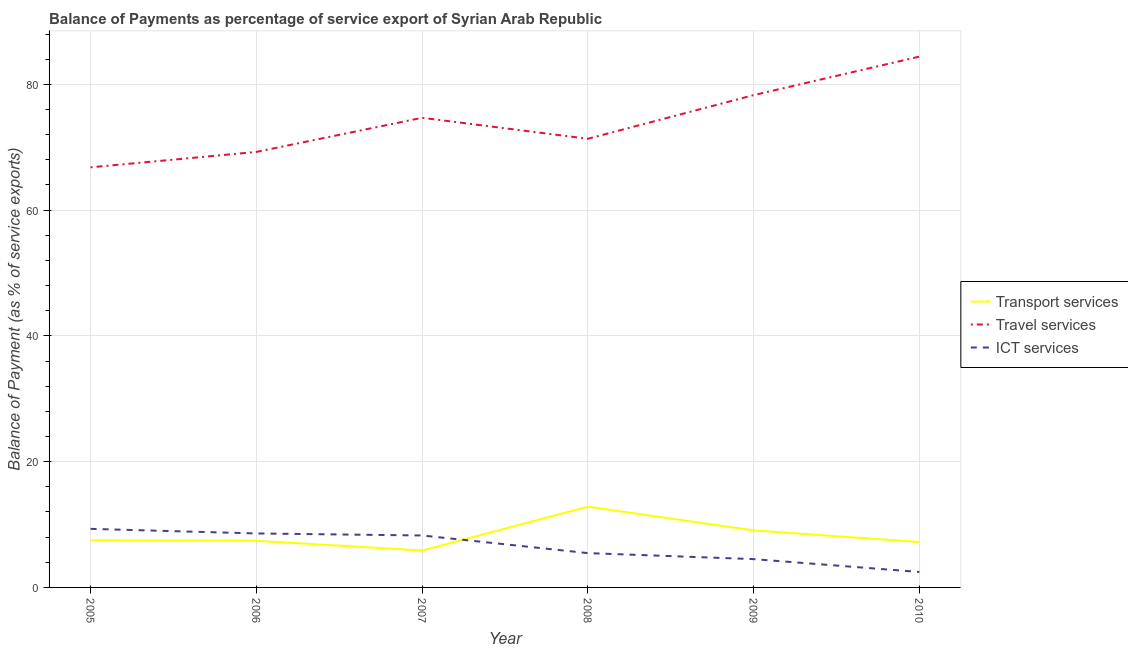Does the line corresponding to balance of payment of transport services intersect with the line corresponding to balance of payment of ict services?
Ensure brevity in your answer.  Yes. What is the balance of payment of transport services in 2006?
Your answer should be compact. 7.42. Across all years, what is the maximum balance of payment of transport services?
Make the answer very short. 12.84. Across all years, what is the minimum balance of payment of travel services?
Your answer should be very brief. 66.8. What is the total balance of payment of travel services in the graph?
Offer a very short reply. 444.79. What is the difference between the balance of payment of transport services in 2007 and that in 2009?
Keep it short and to the point. -3.2. What is the difference between the balance of payment of transport services in 2010 and the balance of payment of ict services in 2009?
Your answer should be compact. 2.72. What is the average balance of payment of transport services per year?
Your answer should be compact. 8.32. In the year 2005, what is the difference between the balance of payment of transport services and balance of payment of travel services?
Offer a terse response. -59.31. What is the ratio of the balance of payment of travel services in 2005 to that in 2006?
Your answer should be compact. 0.96. What is the difference between the highest and the second highest balance of payment of ict services?
Offer a very short reply. 0.73. What is the difference between the highest and the lowest balance of payment of travel services?
Make the answer very short. 17.61. In how many years, is the balance of payment of transport services greater than the average balance of payment of transport services taken over all years?
Your answer should be very brief. 2. Is the sum of the balance of payment of transport services in 2005 and 2006 greater than the maximum balance of payment of ict services across all years?
Provide a short and direct response. Yes. Is it the case that in every year, the sum of the balance of payment of transport services and balance of payment of travel services is greater than the balance of payment of ict services?
Make the answer very short. Yes. Does the balance of payment of ict services monotonically increase over the years?
Provide a short and direct response. No. Is the balance of payment of travel services strictly greater than the balance of payment of ict services over the years?
Make the answer very short. Yes. Is the balance of payment of travel services strictly less than the balance of payment of ict services over the years?
Offer a terse response. No. How many years are there in the graph?
Make the answer very short. 6. Does the graph contain any zero values?
Your response must be concise. No. How are the legend labels stacked?
Your answer should be compact. Vertical. What is the title of the graph?
Your response must be concise. Balance of Payments as percentage of service export of Syrian Arab Republic. What is the label or title of the X-axis?
Provide a short and direct response. Year. What is the label or title of the Y-axis?
Your response must be concise. Balance of Payment (as % of service exports). What is the Balance of Payment (as % of service exports) of Transport services in 2005?
Offer a very short reply. 7.49. What is the Balance of Payment (as % of service exports) of Travel services in 2005?
Offer a terse response. 66.8. What is the Balance of Payment (as % of service exports) in ICT services in 2005?
Give a very brief answer. 9.31. What is the Balance of Payment (as % of service exports) in Transport services in 2006?
Give a very brief answer. 7.42. What is the Balance of Payment (as % of service exports) of Travel services in 2006?
Ensure brevity in your answer.  69.25. What is the Balance of Payment (as % of service exports) in ICT services in 2006?
Your answer should be compact. 8.58. What is the Balance of Payment (as % of service exports) of Transport services in 2007?
Offer a terse response. 5.87. What is the Balance of Payment (as % of service exports) of Travel services in 2007?
Your answer should be very brief. 74.68. What is the Balance of Payment (as % of service exports) of ICT services in 2007?
Ensure brevity in your answer.  8.26. What is the Balance of Payment (as % of service exports) of Transport services in 2008?
Make the answer very short. 12.84. What is the Balance of Payment (as % of service exports) of Travel services in 2008?
Your answer should be compact. 71.35. What is the Balance of Payment (as % of service exports) of ICT services in 2008?
Offer a terse response. 5.46. What is the Balance of Payment (as % of service exports) in Transport services in 2009?
Give a very brief answer. 9.07. What is the Balance of Payment (as % of service exports) in Travel services in 2009?
Make the answer very short. 78.29. What is the Balance of Payment (as % of service exports) in ICT services in 2009?
Your answer should be compact. 4.5. What is the Balance of Payment (as % of service exports) of Transport services in 2010?
Provide a short and direct response. 7.22. What is the Balance of Payment (as % of service exports) in Travel services in 2010?
Keep it short and to the point. 84.41. What is the Balance of Payment (as % of service exports) of ICT services in 2010?
Keep it short and to the point. 2.46. Across all years, what is the maximum Balance of Payment (as % of service exports) of Transport services?
Give a very brief answer. 12.84. Across all years, what is the maximum Balance of Payment (as % of service exports) in Travel services?
Ensure brevity in your answer.  84.41. Across all years, what is the maximum Balance of Payment (as % of service exports) in ICT services?
Make the answer very short. 9.31. Across all years, what is the minimum Balance of Payment (as % of service exports) in Transport services?
Your answer should be compact. 5.87. Across all years, what is the minimum Balance of Payment (as % of service exports) of Travel services?
Keep it short and to the point. 66.8. Across all years, what is the minimum Balance of Payment (as % of service exports) in ICT services?
Your response must be concise. 2.46. What is the total Balance of Payment (as % of service exports) in Transport services in the graph?
Your answer should be compact. 49.91. What is the total Balance of Payment (as % of service exports) in Travel services in the graph?
Provide a short and direct response. 444.79. What is the total Balance of Payment (as % of service exports) of ICT services in the graph?
Ensure brevity in your answer.  38.57. What is the difference between the Balance of Payment (as % of service exports) in Transport services in 2005 and that in 2006?
Give a very brief answer. 0.07. What is the difference between the Balance of Payment (as % of service exports) of Travel services in 2005 and that in 2006?
Provide a succinct answer. -2.45. What is the difference between the Balance of Payment (as % of service exports) of ICT services in 2005 and that in 2006?
Give a very brief answer. 0.73. What is the difference between the Balance of Payment (as % of service exports) in Transport services in 2005 and that in 2007?
Provide a succinct answer. 1.62. What is the difference between the Balance of Payment (as % of service exports) in Travel services in 2005 and that in 2007?
Your answer should be compact. -7.88. What is the difference between the Balance of Payment (as % of service exports) of ICT services in 2005 and that in 2007?
Provide a short and direct response. 1.05. What is the difference between the Balance of Payment (as % of service exports) in Transport services in 2005 and that in 2008?
Your answer should be very brief. -5.35. What is the difference between the Balance of Payment (as % of service exports) of Travel services in 2005 and that in 2008?
Ensure brevity in your answer.  -4.54. What is the difference between the Balance of Payment (as % of service exports) of ICT services in 2005 and that in 2008?
Offer a very short reply. 3.85. What is the difference between the Balance of Payment (as % of service exports) of Transport services in 2005 and that in 2009?
Give a very brief answer. -1.57. What is the difference between the Balance of Payment (as % of service exports) of Travel services in 2005 and that in 2009?
Give a very brief answer. -11.48. What is the difference between the Balance of Payment (as % of service exports) of ICT services in 2005 and that in 2009?
Offer a terse response. 4.81. What is the difference between the Balance of Payment (as % of service exports) in Transport services in 2005 and that in 2010?
Provide a short and direct response. 0.28. What is the difference between the Balance of Payment (as % of service exports) in Travel services in 2005 and that in 2010?
Your response must be concise. -17.61. What is the difference between the Balance of Payment (as % of service exports) in ICT services in 2005 and that in 2010?
Your answer should be very brief. 6.86. What is the difference between the Balance of Payment (as % of service exports) in Transport services in 2006 and that in 2007?
Your answer should be compact. 1.55. What is the difference between the Balance of Payment (as % of service exports) in Travel services in 2006 and that in 2007?
Provide a succinct answer. -5.43. What is the difference between the Balance of Payment (as % of service exports) of ICT services in 2006 and that in 2007?
Your response must be concise. 0.32. What is the difference between the Balance of Payment (as % of service exports) of Transport services in 2006 and that in 2008?
Provide a short and direct response. -5.42. What is the difference between the Balance of Payment (as % of service exports) in Travel services in 2006 and that in 2008?
Offer a terse response. -2.09. What is the difference between the Balance of Payment (as % of service exports) of ICT services in 2006 and that in 2008?
Offer a very short reply. 3.13. What is the difference between the Balance of Payment (as % of service exports) in Transport services in 2006 and that in 2009?
Your answer should be very brief. -1.65. What is the difference between the Balance of Payment (as % of service exports) in Travel services in 2006 and that in 2009?
Ensure brevity in your answer.  -9.03. What is the difference between the Balance of Payment (as % of service exports) of ICT services in 2006 and that in 2009?
Your response must be concise. 4.08. What is the difference between the Balance of Payment (as % of service exports) in Transport services in 2006 and that in 2010?
Your answer should be very brief. 0.2. What is the difference between the Balance of Payment (as % of service exports) in Travel services in 2006 and that in 2010?
Provide a succinct answer. -15.16. What is the difference between the Balance of Payment (as % of service exports) in ICT services in 2006 and that in 2010?
Your answer should be very brief. 6.13. What is the difference between the Balance of Payment (as % of service exports) in Transport services in 2007 and that in 2008?
Your response must be concise. -6.97. What is the difference between the Balance of Payment (as % of service exports) in Travel services in 2007 and that in 2008?
Keep it short and to the point. 3.33. What is the difference between the Balance of Payment (as % of service exports) of ICT services in 2007 and that in 2008?
Offer a very short reply. 2.8. What is the difference between the Balance of Payment (as % of service exports) of Transport services in 2007 and that in 2009?
Give a very brief answer. -3.2. What is the difference between the Balance of Payment (as % of service exports) of Travel services in 2007 and that in 2009?
Provide a succinct answer. -3.6. What is the difference between the Balance of Payment (as % of service exports) in ICT services in 2007 and that in 2009?
Your response must be concise. 3.76. What is the difference between the Balance of Payment (as % of service exports) in Transport services in 2007 and that in 2010?
Keep it short and to the point. -1.35. What is the difference between the Balance of Payment (as % of service exports) in Travel services in 2007 and that in 2010?
Give a very brief answer. -9.73. What is the difference between the Balance of Payment (as % of service exports) in ICT services in 2007 and that in 2010?
Your answer should be very brief. 5.81. What is the difference between the Balance of Payment (as % of service exports) of Transport services in 2008 and that in 2009?
Provide a succinct answer. 3.78. What is the difference between the Balance of Payment (as % of service exports) of Travel services in 2008 and that in 2009?
Offer a very short reply. -6.94. What is the difference between the Balance of Payment (as % of service exports) in ICT services in 2008 and that in 2009?
Your response must be concise. 0.96. What is the difference between the Balance of Payment (as % of service exports) in Transport services in 2008 and that in 2010?
Offer a terse response. 5.63. What is the difference between the Balance of Payment (as % of service exports) of Travel services in 2008 and that in 2010?
Offer a terse response. -13.07. What is the difference between the Balance of Payment (as % of service exports) in ICT services in 2008 and that in 2010?
Your response must be concise. 3. What is the difference between the Balance of Payment (as % of service exports) in Transport services in 2009 and that in 2010?
Offer a very short reply. 1.85. What is the difference between the Balance of Payment (as % of service exports) of Travel services in 2009 and that in 2010?
Provide a short and direct response. -6.13. What is the difference between the Balance of Payment (as % of service exports) in ICT services in 2009 and that in 2010?
Make the answer very short. 2.05. What is the difference between the Balance of Payment (as % of service exports) of Transport services in 2005 and the Balance of Payment (as % of service exports) of Travel services in 2006?
Offer a terse response. -61.76. What is the difference between the Balance of Payment (as % of service exports) in Transport services in 2005 and the Balance of Payment (as % of service exports) in ICT services in 2006?
Your answer should be very brief. -1.09. What is the difference between the Balance of Payment (as % of service exports) in Travel services in 2005 and the Balance of Payment (as % of service exports) in ICT services in 2006?
Ensure brevity in your answer.  58.22. What is the difference between the Balance of Payment (as % of service exports) of Transport services in 2005 and the Balance of Payment (as % of service exports) of Travel services in 2007?
Give a very brief answer. -67.19. What is the difference between the Balance of Payment (as % of service exports) in Transport services in 2005 and the Balance of Payment (as % of service exports) in ICT services in 2007?
Your answer should be very brief. -0.77. What is the difference between the Balance of Payment (as % of service exports) of Travel services in 2005 and the Balance of Payment (as % of service exports) of ICT services in 2007?
Your response must be concise. 58.54. What is the difference between the Balance of Payment (as % of service exports) in Transport services in 2005 and the Balance of Payment (as % of service exports) in Travel services in 2008?
Your answer should be compact. -63.86. What is the difference between the Balance of Payment (as % of service exports) of Transport services in 2005 and the Balance of Payment (as % of service exports) of ICT services in 2008?
Your response must be concise. 2.03. What is the difference between the Balance of Payment (as % of service exports) of Travel services in 2005 and the Balance of Payment (as % of service exports) of ICT services in 2008?
Give a very brief answer. 61.35. What is the difference between the Balance of Payment (as % of service exports) of Transport services in 2005 and the Balance of Payment (as % of service exports) of Travel services in 2009?
Provide a short and direct response. -70.8. What is the difference between the Balance of Payment (as % of service exports) of Transport services in 2005 and the Balance of Payment (as % of service exports) of ICT services in 2009?
Keep it short and to the point. 2.99. What is the difference between the Balance of Payment (as % of service exports) in Travel services in 2005 and the Balance of Payment (as % of service exports) in ICT services in 2009?
Make the answer very short. 62.3. What is the difference between the Balance of Payment (as % of service exports) of Transport services in 2005 and the Balance of Payment (as % of service exports) of Travel services in 2010?
Ensure brevity in your answer.  -76.92. What is the difference between the Balance of Payment (as % of service exports) of Transport services in 2005 and the Balance of Payment (as % of service exports) of ICT services in 2010?
Keep it short and to the point. 5.04. What is the difference between the Balance of Payment (as % of service exports) in Travel services in 2005 and the Balance of Payment (as % of service exports) in ICT services in 2010?
Your answer should be very brief. 64.35. What is the difference between the Balance of Payment (as % of service exports) in Transport services in 2006 and the Balance of Payment (as % of service exports) in Travel services in 2007?
Offer a very short reply. -67.26. What is the difference between the Balance of Payment (as % of service exports) in Transport services in 2006 and the Balance of Payment (as % of service exports) in ICT services in 2007?
Provide a short and direct response. -0.84. What is the difference between the Balance of Payment (as % of service exports) in Travel services in 2006 and the Balance of Payment (as % of service exports) in ICT services in 2007?
Provide a succinct answer. 60.99. What is the difference between the Balance of Payment (as % of service exports) of Transport services in 2006 and the Balance of Payment (as % of service exports) of Travel services in 2008?
Offer a very short reply. -63.93. What is the difference between the Balance of Payment (as % of service exports) of Transport services in 2006 and the Balance of Payment (as % of service exports) of ICT services in 2008?
Your answer should be very brief. 1.96. What is the difference between the Balance of Payment (as % of service exports) of Travel services in 2006 and the Balance of Payment (as % of service exports) of ICT services in 2008?
Provide a succinct answer. 63.8. What is the difference between the Balance of Payment (as % of service exports) in Transport services in 2006 and the Balance of Payment (as % of service exports) in Travel services in 2009?
Your answer should be very brief. -70.87. What is the difference between the Balance of Payment (as % of service exports) of Transport services in 2006 and the Balance of Payment (as % of service exports) of ICT services in 2009?
Your answer should be compact. 2.92. What is the difference between the Balance of Payment (as % of service exports) of Travel services in 2006 and the Balance of Payment (as % of service exports) of ICT services in 2009?
Your answer should be compact. 64.75. What is the difference between the Balance of Payment (as % of service exports) of Transport services in 2006 and the Balance of Payment (as % of service exports) of Travel services in 2010?
Provide a succinct answer. -76.99. What is the difference between the Balance of Payment (as % of service exports) in Transport services in 2006 and the Balance of Payment (as % of service exports) in ICT services in 2010?
Your answer should be very brief. 4.97. What is the difference between the Balance of Payment (as % of service exports) in Travel services in 2006 and the Balance of Payment (as % of service exports) in ICT services in 2010?
Keep it short and to the point. 66.8. What is the difference between the Balance of Payment (as % of service exports) in Transport services in 2007 and the Balance of Payment (as % of service exports) in Travel services in 2008?
Provide a succinct answer. -65.48. What is the difference between the Balance of Payment (as % of service exports) of Transport services in 2007 and the Balance of Payment (as % of service exports) of ICT services in 2008?
Make the answer very short. 0.41. What is the difference between the Balance of Payment (as % of service exports) in Travel services in 2007 and the Balance of Payment (as % of service exports) in ICT services in 2008?
Offer a very short reply. 69.22. What is the difference between the Balance of Payment (as % of service exports) of Transport services in 2007 and the Balance of Payment (as % of service exports) of Travel services in 2009?
Ensure brevity in your answer.  -72.42. What is the difference between the Balance of Payment (as % of service exports) of Transport services in 2007 and the Balance of Payment (as % of service exports) of ICT services in 2009?
Keep it short and to the point. 1.37. What is the difference between the Balance of Payment (as % of service exports) in Travel services in 2007 and the Balance of Payment (as % of service exports) in ICT services in 2009?
Provide a succinct answer. 70.18. What is the difference between the Balance of Payment (as % of service exports) of Transport services in 2007 and the Balance of Payment (as % of service exports) of Travel services in 2010?
Provide a short and direct response. -78.55. What is the difference between the Balance of Payment (as % of service exports) in Transport services in 2007 and the Balance of Payment (as % of service exports) in ICT services in 2010?
Give a very brief answer. 3.41. What is the difference between the Balance of Payment (as % of service exports) in Travel services in 2007 and the Balance of Payment (as % of service exports) in ICT services in 2010?
Make the answer very short. 72.23. What is the difference between the Balance of Payment (as % of service exports) of Transport services in 2008 and the Balance of Payment (as % of service exports) of Travel services in 2009?
Offer a terse response. -65.45. What is the difference between the Balance of Payment (as % of service exports) in Transport services in 2008 and the Balance of Payment (as % of service exports) in ICT services in 2009?
Ensure brevity in your answer.  8.34. What is the difference between the Balance of Payment (as % of service exports) in Travel services in 2008 and the Balance of Payment (as % of service exports) in ICT services in 2009?
Make the answer very short. 66.85. What is the difference between the Balance of Payment (as % of service exports) of Transport services in 2008 and the Balance of Payment (as % of service exports) of Travel services in 2010?
Offer a very short reply. -71.57. What is the difference between the Balance of Payment (as % of service exports) in Transport services in 2008 and the Balance of Payment (as % of service exports) in ICT services in 2010?
Make the answer very short. 10.39. What is the difference between the Balance of Payment (as % of service exports) in Travel services in 2008 and the Balance of Payment (as % of service exports) in ICT services in 2010?
Ensure brevity in your answer.  68.89. What is the difference between the Balance of Payment (as % of service exports) of Transport services in 2009 and the Balance of Payment (as % of service exports) of Travel services in 2010?
Your answer should be compact. -75.35. What is the difference between the Balance of Payment (as % of service exports) of Transport services in 2009 and the Balance of Payment (as % of service exports) of ICT services in 2010?
Make the answer very short. 6.61. What is the difference between the Balance of Payment (as % of service exports) in Travel services in 2009 and the Balance of Payment (as % of service exports) in ICT services in 2010?
Make the answer very short. 75.83. What is the average Balance of Payment (as % of service exports) of Transport services per year?
Your answer should be compact. 8.32. What is the average Balance of Payment (as % of service exports) in Travel services per year?
Offer a terse response. 74.13. What is the average Balance of Payment (as % of service exports) in ICT services per year?
Ensure brevity in your answer.  6.43. In the year 2005, what is the difference between the Balance of Payment (as % of service exports) in Transport services and Balance of Payment (as % of service exports) in Travel services?
Give a very brief answer. -59.31. In the year 2005, what is the difference between the Balance of Payment (as % of service exports) in Transport services and Balance of Payment (as % of service exports) in ICT services?
Provide a succinct answer. -1.82. In the year 2005, what is the difference between the Balance of Payment (as % of service exports) of Travel services and Balance of Payment (as % of service exports) of ICT services?
Offer a terse response. 57.49. In the year 2006, what is the difference between the Balance of Payment (as % of service exports) of Transport services and Balance of Payment (as % of service exports) of Travel services?
Make the answer very short. -61.83. In the year 2006, what is the difference between the Balance of Payment (as % of service exports) of Transport services and Balance of Payment (as % of service exports) of ICT services?
Your response must be concise. -1.16. In the year 2006, what is the difference between the Balance of Payment (as % of service exports) of Travel services and Balance of Payment (as % of service exports) of ICT services?
Give a very brief answer. 60.67. In the year 2007, what is the difference between the Balance of Payment (as % of service exports) of Transport services and Balance of Payment (as % of service exports) of Travel services?
Give a very brief answer. -68.81. In the year 2007, what is the difference between the Balance of Payment (as % of service exports) of Transport services and Balance of Payment (as % of service exports) of ICT services?
Offer a very short reply. -2.39. In the year 2007, what is the difference between the Balance of Payment (as % of service exports) of Travel services and Balance of Payment (as % of service exports) of ICT services?
Ensure brevity in your answer.  66.42. In the year 2008, what is the difference between the Balance of Payment (as % of service exports) of Transport services and Balance of Payment (as % of service exports) of Travel services?
Provide a succinct answer. -58.51. In the year 2008, what is the difference between the Balance of Payment (as % of service exports) of Transport services and Balance of Payment (as % of service exports) of ICT services?
Offer a very short reply. 7.38. In the year 2008, what is the difference between the Balance of Payment (as % of service exports) in Travel services and Balance of Payment (as % of service exports) in ICT services?
Your answer should be compact. 65.89. In the year 2009, what is the difference between the Balance of Payment (as % of service exports) of Transport services and Balance of Payment (as % of service exports) of Travel services?
Provide a succinct answer. -69.22. In the year 2009, what is the difference between the Balance of Payment (as % of service exports) of Transport services and Balance of Payment (as % of service exports) of ICT services?
Provide a short and direct response. 4.57. In the year 2009, what is the difference between the Balance of Payment (as % of service exports) in Travel services and Balance of Payment (as % of service exports) in ICT services?
Your answer should be compact. 73.79. In the year 2010, what is the difference between the Balance of Payment (as % of service exports) of Transport services and Balance of Payment (as % of service exports) of Travel services?
Your answer should be very brief. -77.2. In the year 2010, what is the difference between the Balance of Payment (as % of service exports) in Transport services and Balance of Payment (as % of service exports) in ICT services?
Your response must be concise. 4.76. In the year 2010, what is the difference between the Balance of Payment (as % of service exports) in Travel services and Balance of Payment (as % of service exports) in ICT services?
Ensure brevity in your answer.  81.96. What is the ratio of the Balance of Payment (as % of service exports) in Transport services in 2005 to that in 2006?
Your answer should be compact. 1.01. What is the ratio of the Balance of Payment (as % of service exports) in Travel services in 2005 to that in 2006?
Provide a short and direct response. 0.96. What is the ratio of the Balance of Payment (as % of service exports) in ICT services in 2005 to that in 2006?
Provide a short and direct response. 1.08. What is the ratio of the Balance of Payment (as % of service exports) of Transport services in 2005 to that in 2007?
Your answer should be very brief. 1.28. What is the ratio of the Balance of Payment (as % of service exports) in Travel services in 2005 to that in 2007?
Keep it short and to the point. 0.89. What is the ratio of the Balance of Payment (as % of service exports) of ICT services in 2005 to that in 2007?
Offer a terse response. 1.13. What is the ratio of the Balance of Payment (as % of service exports) in Transport services in 2005 to that in 2008?
Make the answer very short. 0.58. What is the ratio of the Balance of Payment (as % of service exports) in Travel services in 2005 to that in 2008?
Offer a very short reply. 0.94. What is the ratio of the Balance of Payment (as % of service exports) of ICT services in 2005 to that in 2008?
Offer a very short reply. 1.71. What is the ratio of the Balance of Payment (as % of service exports) in Transport services in 2005 to that in 2009?
Offer a terse response. 0.83. What is the ratio of the Balance of Payment (as % of service exports) of Travel services in 2005 to that in 2009?
Make the answer very short. 0.85. What is the ratio of the Balance of Payment (as % of service exports) in ICT services in 2005 to that in 2009?
Offer a very short reply. 2.07. What is the ratio of the Balance of Payment (as % of service exports) in Transport services in 2005 to that in 2010?
Your answer should be very brief. 1.04. What is the ratio of the Balance of Payment (as % of service exports) in Travel services in 2005 to that in 2010?
Ensure brevity in your answer.  0.79. What is the ratio of the Balance of Payment (as % of service exports) in ICT services in 2005 to that in 2010?
Provide a short and direct response. 3.79. What is the ratio of the Balance of Payment (as % of service exports) of Transport services in 2006 to that in 2007?
Your answer should be very brief. 1.26. What is the ratio of the Balance of Payment (as % of service exports) of Travel services in 2006 to that in 2007?
Provide a succinct answer. 0.93. What is the ratio of the Balance of Payment (as % of service exports) in ICT services in 2006 to that in 2007?
Offer a terse response. 1.04. What is the ratio of the Balance of Payment (as % of service exports) in Transport services in 2006 to that in 2008?
Your answer should be compact. 0.58. What is the ratio of the Balance of Payment (as % of service exports) in Travel services in 2006 to that in 2008?
Keep it short and to the point. 0.97. What is the ratio of the Balance of Payment (as % of service exports) in ICT services in 2006 to that in 2008?
Provide a succinct answer. 1.57. What is the ratio of the Balance of Payment (as % of service exports) of Transport services in 2006 to that in 2009?
Ensure brevity in your answer.  0.82. What is the ratio of the Balance of Payment (as % of service exports) in Travel services in 2006 to that in 2009?
Ensure brevity in your answer.  0.88. What is the ratio of the Balance of Payment (as % of service exports) of ICT services in 2006 to that in 2009?
Provide a succinct answer. 1.91. What is the ratio of the Balance of Payment (as % of service exports) in Transport services in 2006 to that in 2010?
Your answer should be compact. 1.03. What is the ratio of the Balance of Payment (as % of service exports) in Travel services in 2006 to that in 2010?
Offer a very short reply. 0.82. What is the ratio of the Balance of Payment (as % of service exports) in ICT services in 2006 to that in 2010?
Offer a very short reply. 3.5. What is the ratio of the Balance of Payment (as % of service exports) of Transport services in 2007 to that in 2008?
Your answer should be compact. 0.46. What is the ratio of the Balance of Payment (as % of service exports) in Travel services in 2007 to that in 2008?
Keep it short and to the point. 1.05. What is the ratio of the Balance of Payment (as % of service exports) in ICT services in 2007 to that in 2008?
Provide a succinct answer. 1.51. What is the ratio of the Balance of Payment (as % of service exports) of Transport services in 2007 to that in 2009?
Provide a short and direct response. 0.65. What is the ratio of the Balance of Payment (as % of service exports) in Travel services in 2007 to that in 2009?
Provide a short and direct response. 0.95. What is the ratio of the Balance of Payment (as % of service exports) of ICT services in 2007 to that in 2009?
Ensure brevity in your answer.  1.84. What is the ratio of the Balance of Payment (as % of service exports) in Transport services in 2007 to that in 2010?
Provide a short and direct response. 0.81. What is the ratio of the Balance of Payment (as % of service exports) of Travel services in 2007 to that in 2010?
Make the answer very short. 0.88. What is the ratio of the Balance of Payment (as % of service exports) of ICT services in 2007 to that in 2010?
Your response must be concise. 3.36. What is the ratio of the Balance of Payment (as % of service exports) of Transport services in 2008 to that in 2009?
Your answer should be compact. 1.42. What is the ratio of the Balance of Payment (as % of service exports) of Travel services in 2008 to that in 2009?
Make the answer very short. 0.91. What is the ratio of the Balance of Payment (as % of service exports) in ICT services in 2008 to that in 2009?
Keep it short and to the point. 1.21. What is the ratio of the Balance of Payment (as % of service exports) of Transport services in 2008 to that in 2010?
Make the answer very short. 1.78. What is the ratio of the Balance of Payment (as % of service exports) of Travel services in 2008 to that in 2010?
Keep it short and to the point. 0.85. What is the ratio of the Balance of Payment (as % of service exports) in ICT services in 2008 to that in 2010?
Offer a very short reply. 2.22. What is the ratio of the Balance of Payment (as % of service exports) in Transport services in 2009 to that in 2010?
Your answer should be compact. 1.26. What is the ratio of the Balance of Payment (as % of service exports) of Travel services in 2009 to that in 2010?
Ensure brevity in your answer.  0.93. What is the ratio of the Balance of Payment (as % of service exports) of ICT services in 2009 to that in 2010?
Ensure brevity in your answer.  1.83. What is the difference between the highest and the second highest Balance of Payment (as % of service exports) of Transport services?
Give a very brief answer. 3.78. What is the difference between the highest and the second highest Balance of Payment (as % of service exports) in Travel services?
Provide a short and direct response. 6.13. What is the difference between the highest and the second highest Balance of Payment (as % of service exports) of ICT services?
Keep it short and to the point. 0.73. What is the difference between the highest and the lowest Balance of Payment (as % of service exports) in Transport services?
Your answer should be compact. 6.97. What is the difference between the highest and the lowest Balance of Payment (as % of service exports) in Travel services?
Provide a succinct answer. 17.61. What is the difference between the highest and the lowest Balance of Payment (as % of service exports) in ICT services?
Offer a very short reply. 6.86. 